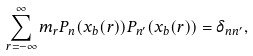<formula> <loc_0><loc_0><loc_500><loc_500>\sum _ { r = - \infty } ^ { \infty } m _ { r } P _ { n } ( x _ { b } ( r ) ) P _ { n ^ { \prime } } ( x _ { b } ( r ) ) = \delta _ { n n ^ { \prime } } ,</formula> 